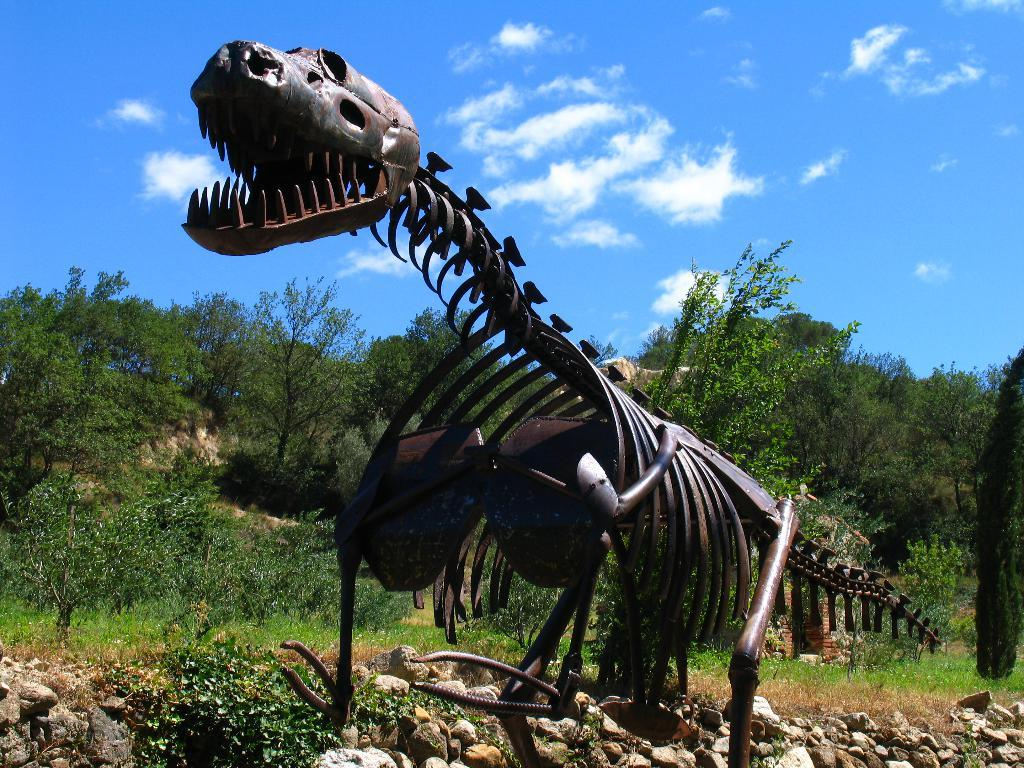What is the main subject in the center of the image? There is a black color dinosaur structure in the center of the image. What can be seen in the background of the image? There is sky, clouds, trees, plants, grass, and stones visible in the background of the image. What type of toothpaste is being used to clean the dinosaur structure in the image? There is no toothpaste present in the image, and the dinosaur structure is not being cleaned. 